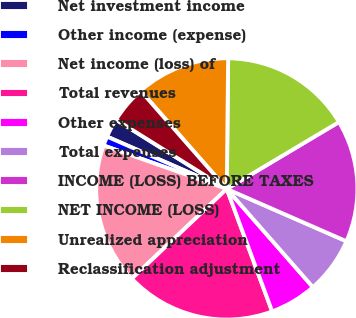Convert chart to OTSL. <chart><loc_0><loc_0><loc_500><loc_500><pie_chart><fcel>Net investment income<fcel>Other income (expense)<fcel>Net income (loss) of<fcel>Total revenues<fcel>Other expenses<fcel>Total expenses<fcel>INCOME (LOSS) BEFORE TAXES<fcel>NET INCOME (LOSS)<fcel>Unrealized appreciation<fcel>Reclassification adjustment<nl><fcel>2.33%<fcel>1.16%<fcel>17.44%<fcel>18.6%<fcel>5.81%<fcel>6.98%<fcel>15.12%<fcel>16.28%<fcel>11.63%<fcel>4.65%<nl></chart> 